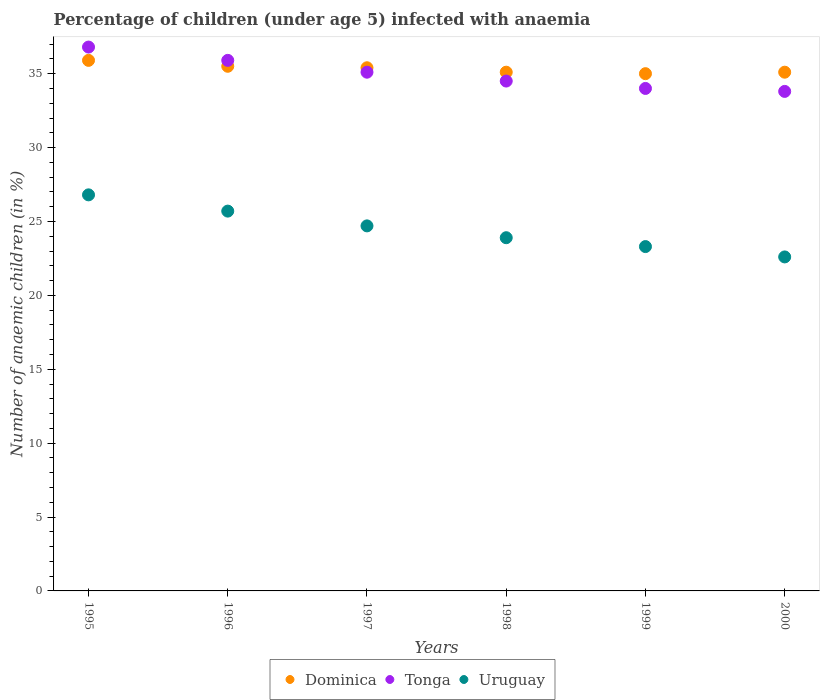How many different coloured dotlines are there?
Your response must be concise. 3. What is the percentage of children infected with anaemia in in Tonga in 1999?
Keep it short and to the point. 34. Across all years, what is the maximum percentage of children infected with anaemia in in Tonga?
Your answer should be compact. 36.8. Across all years, what is the minimum percentage of children infected with anaemia in in Tonga?
Your answer should be compact. 33.8. In which year was the percentage of children infected with anaemia in in Dominica maximum?
Offer a very short reply. 1995. In which year was the percentage of children infected with anaemia in in Dominica minimum?
Your answer should be compact. 1999. What is the total percentage of children infected with anaemia in in Dominica in the graph?
Your response must be concise. 212. What is the difference between the percentage of children infected with anaemia in in Uruguay in 1995 and that in 1996?
Ensure brevity in your answer.  1.1. What is the difference between the percentage of children infected with anaemia in in Dominica in 1995 and the percentage of children infected with anaemia in in Tonga in 2000?
Make the answer very short. 2.1. What is the average percentage of children infected with anaemia in in Uruguay per year?
Make the answer very short. 24.5. In the year 1995, what is the difference between the percentage of children infected with anaemia in in Tonga and percentage of children infected with anaemia in in Dominica?
Make the answer very short. 0.9. In how many years, is the percentage of children infected with anaemia in in Dominica greater than 27 %?
Ensure brevity in your answer.  6. What is the ratio of the percentage of children infected with anaemia in in Dominica in 1998 to that in 2000?
Provide a short and direct response. 1. Is the percentage of children infected with anaemia in in Tonga in 1995 less than that in 1997?
Provide a succinct answer. No. What is the difference between the highest and the second highest percentage of children infected with anaemia in in Tonga?
Ensure brevity in your answer.  0.9. What is the difference between the highest and the lowest percentage of children infected with anaemia in in Uruguay?
Keep it short and to the point. 4.2. In how many years, is the percentage of children infected with anaemia in in Tonga greater than the average percentage of children infected with anaemia in in Tonga taken over all years?
Your answer should be compact. 3. Is the sum of the percentage of children infected with anaemia in in Dominica in 1997 and 1999 greater than the maximum percentage of children infected with anaemia in in Tonga across all years?
Your response must be concise. Yes. Is it the case that in every year, the sum of the percentage of children infected with anaemia in in Tonga and percentage of children infected with anaemia in in Uruguay  is greater than the percentage of children infected with anaemia in in Dominica?
Give a very brief answer. Yes. Is the percentage of children infected with anaemia in in Uruguay strictly less than the percentage of children infected with anaemia in in Tonga over the years?
Make the answer very short. Yes. How many years are there in the graph?
Make the answer very short. 6. Are the values on the major ticks of Y-axis written in scientific E-notation?
Your response must be concise. No. Does the graph contain any zero values?
Make the answer very short. No. Where does the legend appear in the graph?
Provide a short and direct response. Bottom center. How many legend labels are there?
Your response must be concise. 3. How are the legend labels stacked?
Your answer should be compact. Horizontal. What is the title of the graph?
Make the answer very short. Percentage of children (under age 5) infected with anaemia. Does "Nicaragua" appear as one of the legend labels in the graph?
Make the answer very short. No. What is the label or title of the Y-axis?
Your answer should be compact. Number of anaemic children (in %). What is the Number of anaemic children (in %) in Dominica in 1995?
Offer a very short reply. 35.9. What is the Number of anaemic children (in %) in Tonga in 1995?
Your response must be concise. 36.8. What is the Number of anaemic children (in %) of Uruguay in 1995?
Ensure brevity in your answer.  26.8. What is the Number of anaemic children (in %) in Dominica in 1996?
Give a very brief answer. 35.5. What is the Number of anaemic children (in %) of Tonga in 1996?
Provide a succinct answer. 35.9. What is the Number of anaemic children (in %) in Uruguay in 1996?
Your answer should be very brief. 25.7. What is the Number of anaemic children (in %) in Dominica in 1997?
Your answer should be compact. 35.4. What is the Number of anaemic children (in %) in Tonga in 1997?
Make the answer very short. 35.1. What is the Number of anaemic children (in %) of Uruguay in 1997?
Give a very brief answer. 24.7. What is the Number of anaemic children (in %) in Dominica in 1998?
Provide a succinct answer. 35.1. What is the Number of anaemic children (in %) in Tonga in 1998?
Ensure brevity in your answer.  34.5. What is the Number of anaemic children (in %) in Uruguay in 1998?
Your answer should be compact. 23.9. What is the Number of anaemic children (in %) of Dominica in 1999?
Ensure brevity in your answer.  35. What is the Number of anaemic children (in %) in Tonga in 1999?
Keep it short and to the point. 34. What is the Number of anaemic children (in %) of Uruguay in 1999?
Your answer should be very brief. 23.3. What is the Number of anaemic children (in %) in Dominica in 2000?
Ensure brevity in your answer.  35.1. What is the Number of anaemic children (in %) of Tonga in 2000?
Give a very brief answer. 33.8. What is the Number of anaemic children (in %) in Uruguay in 2000?
Your response must be concise. 22.6. Across all years, what is the maximum Number of anaemic children (in %) in Dominica?
Your response must be concise. 35.9. Across all years, what is the maximum Number of anaemic children (in %) of Tonga?
Offer a terse response. 36.8. Across all years, what is the maximum Number of anaemic children (in %) of Uruguay?
Your answer should be very brief. 26.8. Across all years, what is the minimum Number of anaemic children (in %) in Dominica?
Provide a succinct answer. 35. Across all years, what is the minimum Number of anaemic children (in %) in Tonga?
Provide a succinct answer. 33.8. Across all years, what is the minimum Number of anaemic children (in %) in Uruguay?
Keep it short and to the point. 22.6. What is the total Number of anaemic children (in %) in Dominica in the graph?
Give a very brief answer. 212. What is the total Number of anaemic children (in %) of Tonga in the graph?
Give a very brief answer. 210.1. What is the total Number of anaemic children (in %) of Uruguay in the graph?
Offer a terse response. 147. What is the difference between the Number of anaemic children (in %) of Dominica in 1995 and that in 1996?
Keep it short and to the point. 0.4. What is the difference between the Number of anaemic children (in %) in Uruguay in 1995 and that in 1996?
Your answer should be compact. 1.1. What is the difference between the Number of anaemic children (in %) in Tonga in 1995 and that in 1997?
Your response must be concise. 1.7. What is the difference between the Number of anaemic children (in %) of Dominica in 1995 and that in 1998?
Make the answer very short. 0.8. What is the difference between the Number of anaemic children (in %) in Dominica in 1995 and that in 1999?
Your response must be concise. 0.9. What is the difference between the Number of anaemic children (in %) of Tonga in 1995 and that in 2000?
Your response must be concise. 3. What is the difference between the Number of anaemic children (in %) in Dominica in 1996 and that in 1997?
Offer a terse response. 0.1. What is the difference between the Number of anaemic children (in %) in Tonga in 1996 and that in 1997?
Provide a short and direct response. 0.8. What is the difference between the Number of anaemic children (in %) in Uruguay in 1996 and that in 1997?
Your answer should be very brief. 1. What is the difference between the Number of anaemic children (in %) of Tonga in 1996 and that in 1998?
Offer a very short reply. 1.4. What is the difference between the Number of anaemic children (in %) in Tonga in 1996 and that in 1999?
Keep it short and to the point. 1.9. What is the difference between the Number of anaemic children (in %) of Uruguay in 1996 and that in 1999?
Your answer should be very brief. 2.4. What is the difference between the Number of anaemic children (in %) in Dominica in 1996 and that in 2000?
Provide a short and direct response. 0.4. What is the difference between the Number of anaemic children (in %) of Uruguay in 1996 and that in 2000?
Make the answer very short. 3.1. What is the difference between the Number of anaemic children (in %) in Dominica in 1997 and that in 1998?
Your response must be concise. 0.3. What is the difference between the Number of anaemic children (in %) in Uruguay in 1997 and that in 1998?
Give a very brief answer. 0.8. What is the difference between the Number of anaemic children (in %) in Tonga in 1997 and that in 1999?
Offer a terse response. 1.1. What is the difference between the Number of anaemic children (in %) in Uruguay in 1997 and that in 1999?
Make the answer very short. 1.4. What is the difference between the Number of anaemic children (in %) in Uruguay in 1997 and that in 2000?
Provide a short and direct response. 2.1. What is the difference between the Number of anaemic children (in %) of Dominica in 1998 and that in 1999?
Ensure brevity in your answer.  0.1. What is the difference between the Number of anaemic children (in %) of Tonga in 1998 and that in 1999?
Offer a terse response. 0.5. What is the difference between the Number of anaemic children (in %) of Uruguay in 1998 and that in 1999?
Your answer should be compact. 0.6. What is the difference between the Number of anaemic children (in %) in Tonga in 1998 and that in 2000?
Provide a succinct answer. 0.7. What is the difference between the Number of anaemic children (in %) in Dominica in 1999 and that in 2000?
Provide a succinct answer. -0.1. What is the difference between the Number of anaemic children (in %) of Dominica in 1995 and the Number of anaemic children (in %) of Uruguay in 1996?
Your response must be concise. 10.2. What is the difference between the Number of anaemic children (in %) of Tonga in 1995 and the Number of anaemic children (in %) of Uruguay in 1996?
Ensure brevity in your answer.  11.1. What is the difference between the Number of anaemic children (in %) in Dominica in 1995 and the Number of anaemic children (in %) in Tonga in 1997?
Give a very brief answer. 0.8. What is the difference between the Number of anaemic children (in %) of Dominica in 1995 and the Number of anaemic children (in %) of Uruguay in 1997?
Provide a short and direct response. 11.2. What is the difference between the Number of anaemic children (in %) in Dominica in 1995 and the Number of anaemic children (in %) in Uruguay in 1998?
Your answer should be compact. 12. What is the difference between the Number of anaemic children (in %) in Tonga in 1995 and the Number of anaemic children (in %) in Uruguay in 1998?
Provide a succinct answer. 12.9. What is the difference between the Number of anaemic children (in %) in Tonga in 1995 and the Number of anaemic children (in %) in Uruguay in 1999?
Your answer should be very brief. 13.5. What is the difference between the Number of anaemic children (in %) of Dominica in 1996 and the Number of anaemic children (in %) of Uruguay in 1997?
Your response must be concise. 10.8. What is the difference between the Number of anaemic children (in %) of Dominica in 1996 and the Number of anaemic children (in %) of Tonga in 1998?
Provide a succinct answer. 1. What is the difference between the Number of anaemic children (in %) of Dominica in 1996 and the Number of anaemic children (in %) of Uruguay in 1998?
Make the answer very short. 11.6. What is the difference between the Number of anaemic children (in %) of Tonga in 1996 and the Number of anaemic children (in %) of Uruguay in 1998?
Provide a short and direct response. 12. What is the difference between the Number of anaemic children (in %) in Dominica in 1996 and the Number of anaemic children (in %) in Tonga in 1999?
Offer a terse response. 1.5. What is the difference between the Number of anaemic children (in %) in Tonga in 1996 and the Number of anaemic children (in %) in Uruguay in 2000?
Your answer should be very brief. 13.3. What is the difference between the Number of anaemic children (in %) of Dominica in 1997 and the Number of anaemic children (in %) of Uruguay in 1998?
Ensure brevity in your answer.  11.5. What is the difference between the Number of anaemic children (in %) in Tonga in 1997 and the Number of anaemic children (in %) in Uruguay in 1998?
Your answer should be very brief. 11.2. What is the difference between the Number of anaemic children (in %) in Dominica in 1997 and the Number of anaemic children (in %) in Uruguay in 1999?
Offer a very short reply. 12.1. What is the difference between the Number of anaemic children (in %) of Tonga in 1997 and the Number of anaemic children (in %) of Uruguay in 1999?
Keep it short and to the point. 11.8. What is the difference between the Number of anaemic children (in %) in Dominica in 1998 and the Number of anaemic children (in %) in Tonga in 2000?
Provide a short and direct response. 1.3. What is the average Number of anaemic children (in %) of Dominica per year?
Offer a very short reply. 35.33. What is the average Number of anaemic children (in %) of Tonga per year?
Give a very brief answer. 35.02. What is the average Number of anaemic children (in %) in Uruguay per year?
Provide a short and direct response. 24.5. In the year 1995, what is the difference between the Number of anaemic children (in %) of Dominica and Number of anaemic children (in %) of Tonga?
Your answer should be very brief. -0.9. In the year 1995, what is the difference between the Number of anaemic children (in %) of Dominica and Number of anaemic children (in %) of Uruguay?
Your answer should be compact. 9.1. In the year 1995, what is the difference between the Number of anaemic children (in %) in Tonga and Number of anaemic children (in %) in Uruguay?
Offer a terse response. 10. In the year 1996, what is the difference between the Number of anaemic children (in %) of Dominica and Number of anaemic children (in %) of Tonga?
Give a very brief answer. -0.4. In the year 1996, what is the difference between the Number of anaemic children (in %) in Dominica and Number of anaemic children (in %) in Uruguay?
Provide a succinct answer. 9.8. In the year 1996, what is the difference between the Number of anaemic children (in %) of Tonga and Number of anaemic children (in %) of Uruguay?
Your response must be concise. 10.2. In the year 1998, what is the difference between the Number of anaemic children (in %) in Dominica and Number of anaemic children (in %) in Tonga?
Give a very brief answer. 0.6. In the year 1998, what is the difference between the Number of anaemic children (in %) of Dominica and Number of anaemic children (in %) of Uruguay?
Offer a terse response. 11.2. In the year 1999, what is the difference between the Number of anaemic children (in %) in Tonga and Number of anaemic children (in %) in Uruguay?
Provide a succinct answer. 10.7. In the year 2000, what is the difference between the Number of anaemic children (in %) of Dominica and Number of anaemic children (in %) of Tonga?
Keep it short and to the point. 1.3. In the year 2000, what is the difference between the Number of anaemic children (in %) of Tonga and Number of anaemic children (in %) of Uruguay?
Provide a short and direct response. 11.2. What is the ratio of the Number of anaemic children (in %) of Dominica in 1995 to that in 1996?
Offer a very short reply. 1.01. What is the ratio of the Number of anaemic children (in %) in Tonga in 1995 to that in 1996?
Your response must be concise. 1.03. What is the ratio of the Number of anaemic children (in %) of Uruguay in 1995 to that in 1996?
Offer a very short reply. 1.04. What is the ratio of the Number of anaemic children (in %) of Dominica in 1995 to that in 1997?
Provide a short and direct response. 1.01. What is the ratio of the Number of anaemic children (in %) in Tonga in 1995 to that in 1997?
Your response must be concise. 1.05. What is the ratio of the Number of anaemic children (in %) in Uruguay in 1995 to that in 1997?
Your response must be concise. 1.08. What is the ratio of the Number of anaemic children (in %) of Dominica in 1995 to that in 1998?
Offer a very short reply. 1.02. What is the ratio of the Number of anaemic children (in %) of Tonga in 1995 to that in 1998?
Give a very brief answer. 1.07. What is the ratio of the Number of anaemic children (in %) in Uruguay in 1995 to that in 1998?
Make the answer very short. 1.12. What is the ratio of the Number of anaemic children (in %) of Dominica in 1995 to that in 1999?
Ensure brevity in your answer.  1.03. What is the ratio of the Number of anaemic children (in %) in Tonga in 1995 to that in 1999?
Offer a terse response. 1.08. What is the ratio of the Number of anaemic children (in %) in Uruguay in 1995 to that in 1999?
Offer a terse response. 1.15. What is the ratio of the Number of anaemic children (in %) of Dominica in 1995 to that in 2000?
Offer a terse response. 1.02. What is the ratio of the Number of anaemic children (in %) in Tonga in 1995 to that in 2000?
Provide a succinct answer. 1.09. What is the ratio of the Number of anaemic children (in %) of Uruguay in 1995 to that in 2000?
Your answer should be compact. 1.19. What is the ratio of the Number of anaemic children (in %) of Dominica in 1996 to that in 1997?
Your response must be concise. 1. What is the ratio of the Number of anaemic children (in %) in Tonga in 1996 to that in 1997?
Your response must be concise. 1.02. What is the ratio of the Number of anaemic children (in %) of Uruguay in 1996 to that in 1997?
Make the answer very short. 1.04. What is the ratio of the Number of anaemic children (in %) of Dominica in 1996 to that in 1998?
Give a very brief answer. 1.01. What is the ratio of the Number of anaemic children (in %) in Tonga in 1996 to that in 1998?
Ensure brevity in your answer.  1.04. What is the ratio of the Number of anaemic children (in %) of Uruguay in 1996 to that in 1998?
Your answer should be very brief. 1.08. What is the ratio of the Number of anaemic children (in %) in Dominica in 1996 to that in 1999?
Your response must be concise. 1.01. What is the ratio of the Number of anaemic children (in %) in Tonga in 1996 to that in 1999?
Provide a short and direct response. 1.06. What is the ratio of the Number of anaemic children (in %) in Uruguay in 1996 to that in 1999?
Give a very brief answer. 1.1. What is the ratio of the Number of anaemic children (in %) in Dominica in 1996 to that in 2000?
Your answer should be compact. 1.01. What is the ratio of the Number of anaemic children (in %) in Tonga in 1996 to that in 2000?
Provide a succinct answer. 1.06. What is the ratio of the Number of anaemic children (in %) of Uruguay in 1996 to that in 2000?
Provide a succinct answer. 1.14. What is the ratio of the Number of anaemic children (in %) of Dominica in 1997 to that in 1998?
Your response must be concise. 1.01. What is the ratio of the Number of anaemic children (in %) in Tonga in 1997 to that in 1998?
Your response must be concise. 1.02. What is the ratio of the Number of anaemic children (in %) in Uruguay in 1997 to that in 1998?
Offer a terse response. 1.03. What is the ratio of the Number of anaemic children (in %) of Dominica in 1997 to that in 1999?
Ensure brevity in your answer.  1.01. What is the ratio of the Number of anaemic children (in %) in Tonga in 1997 to that in 1999?
Your answer should be compact. 1.03. What is the ratio of the Number of anaemic children (in %) in Uruguay in 1997 to that in 1999?
Your response must be concise. 1.06. What is the ratio of the Number of anaemic children (in %) of Dominica in 1997 to that in 2000?
Your response must be concise. 1.01. What is the ratio of the Number of anaemic children (in %) in Tonga in 1997 to that in 2000?
Offer a terse response. 1.04. What is the ratio of the Number of anaemic children (in %) of Uruguay in 1997 to that in 2000?
Ensure brevity in your answer.  1.09. What is the ratio of the Number of anaemic children (in %) of Dominica in 1998 to that in 1999?
Provide a short and direct response. 1. What is the ratio of the Number of anaemic children (in %) in Tonga in 1998 to that in 1999?
Offer a terse response. 1.01. What is the ratio of the Number of anaemic children (in %) of Uruguay in 1998 to that in 1999?
Offer a very short reply. 1.03. What is the ratio of the Number of anaemic children (in %) in Dominica in 1998 to that in 2000?
Ensure brevity in your answer.  1. What is the ratio of the Number of anaemic children (in %) in Tonga in 1998 to that in 2000?
Your answer should be very brief. 1.02. What is the ratio of the Number of anaemic children (in %) of Uruguay in 1998 to that in 2000?
Provide a short and direct response. 1.06. What is the ratio of the Number of anaemic children (in %) of Dominica in 1999 to that in 2000?
Provide a succinct answer. 1. What is the ratio of the Number of anaemic children (in %) of Tonga in 1999 to that in 2000?
Make the answer very short. 1.01. What is the ratio of the Number of anaemic children (in %) in Uruguay in 1999 to that in 2000?
Ensure brevity in your answer.  1.03. What is the difference between the highest and the second highest Number of anaemic children (in %) of Tonga?
Make the answer very short. 0.9. 